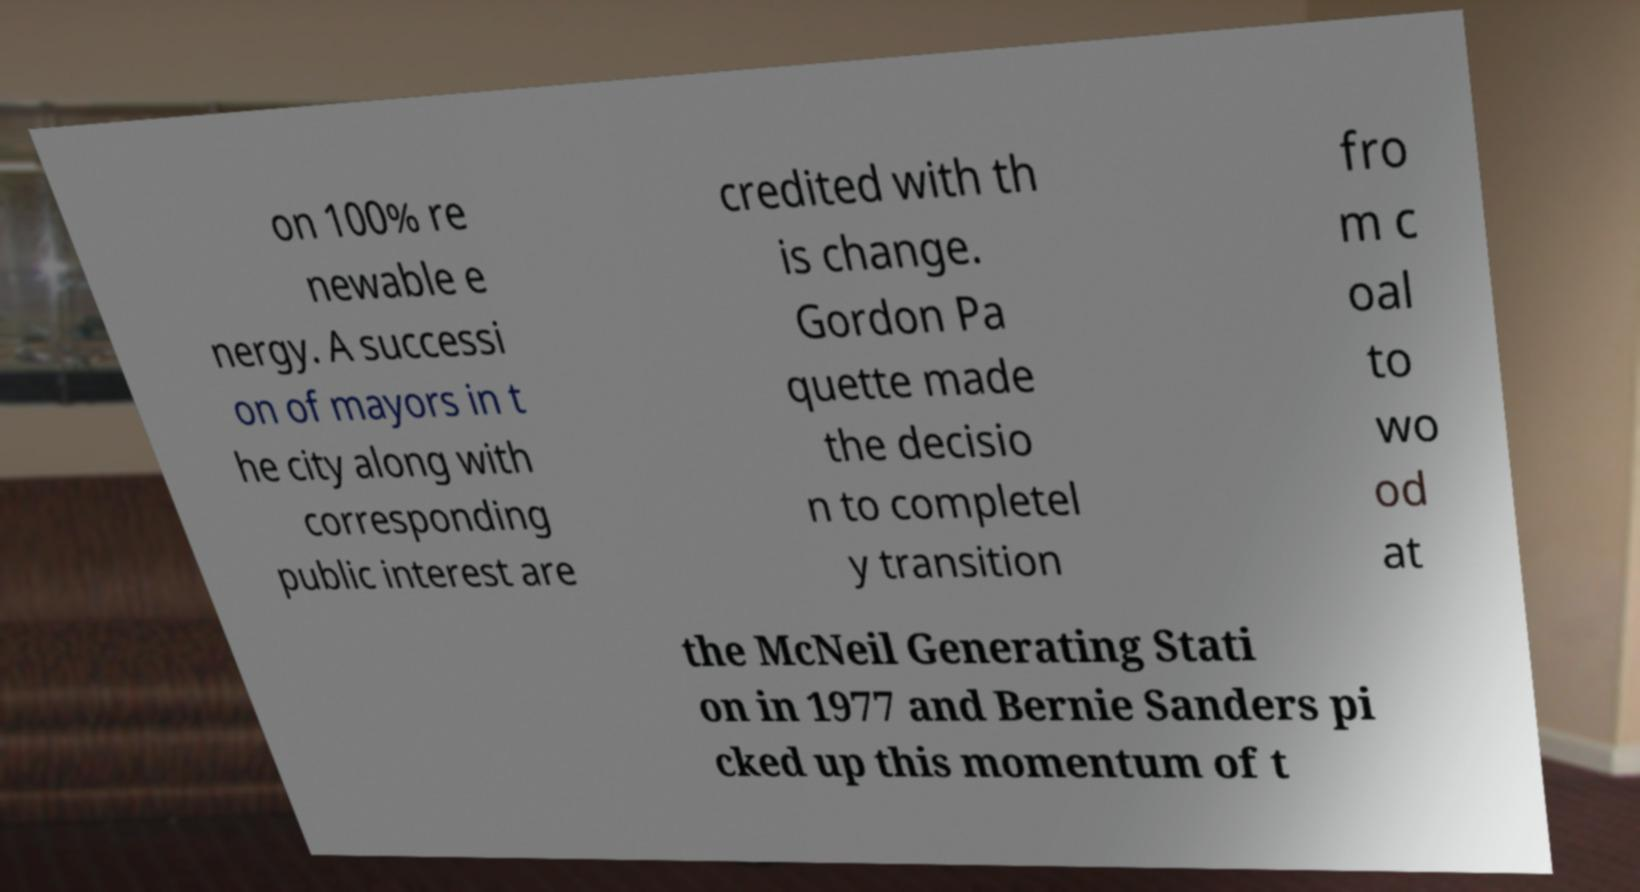Can you accurately transcribe the text from the provided image for me? on 100% re newable e nergy. A successi on of mayors in t he city along with corresponding public interest are credited with th is change. Gordon Pa quette made the decisio n to completel y transition fro m c oal to wo od at the McNeil Generating Stati on in 1977 and Bernie Sanders pi cked up this momentum of t 